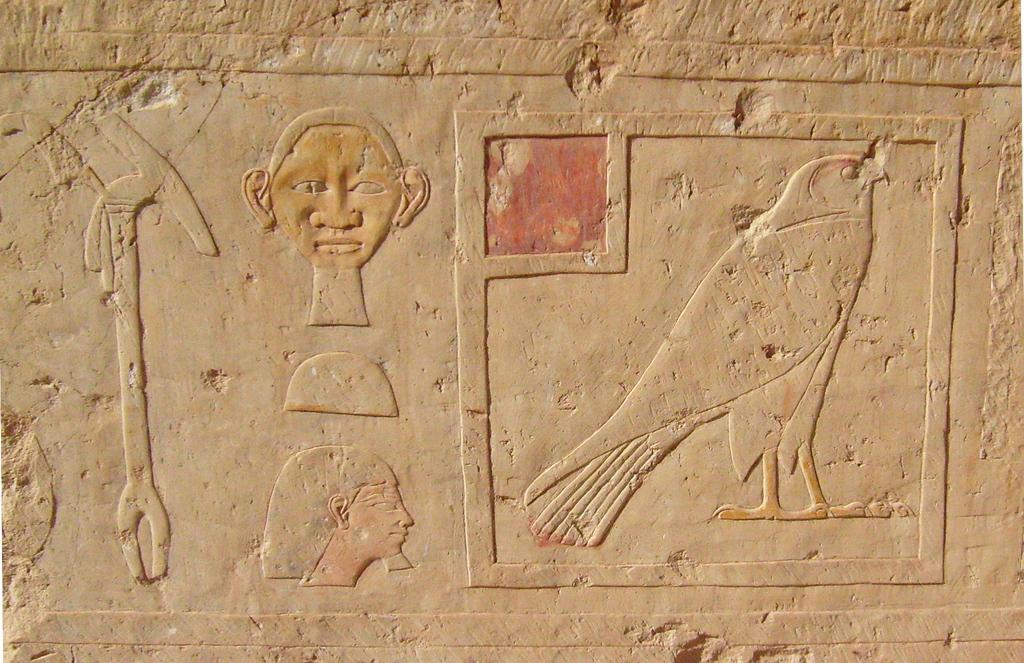What can be seen on the wall in the image? There are carvings on the wall in the image. What type of paint is used for the carvings on the wall in the image? There is no information about the type of paint used for the carvings in the image. In fact, the image does not mention paint at all. 